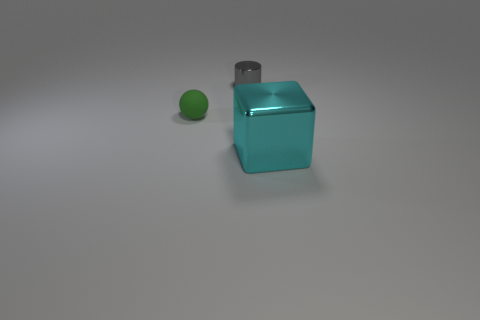Are there any other things that are the same size as the block?
Provide a short and direct response. No. Is the number of small spheres that are behind the green matte ball less than the number of tiny matte objects that are to the left of the tiny metal cylinder?
Your answer should be compact. Yes. There is a metallic thing that is right of the small gray metal cylinder; what size is it?
Give a very brief answer. Large. Do the metallic cylinder and the ball have the same size?
Provide a succinct answer. Yes. What number of objects are in front of the green matte thing and to the left of the large cyan object?
Ensure brevity in your answer.  0. What number of brown things are either matte spheres or shiny objects?
Your response must be concise. 0. How many rubber objects are gray things or big brown objects?
Offer a very short reply. 0. Are there any tiny cylinders?
Make the answer very short. Yes. Is the green matte thing the same shape as the cyan metallic thing?
Provide a short and direct response. No. What number of large cyan cubes are in front of the small thing in front of the object behind the tiny green matte object?
Your answer should be compact. 1. 